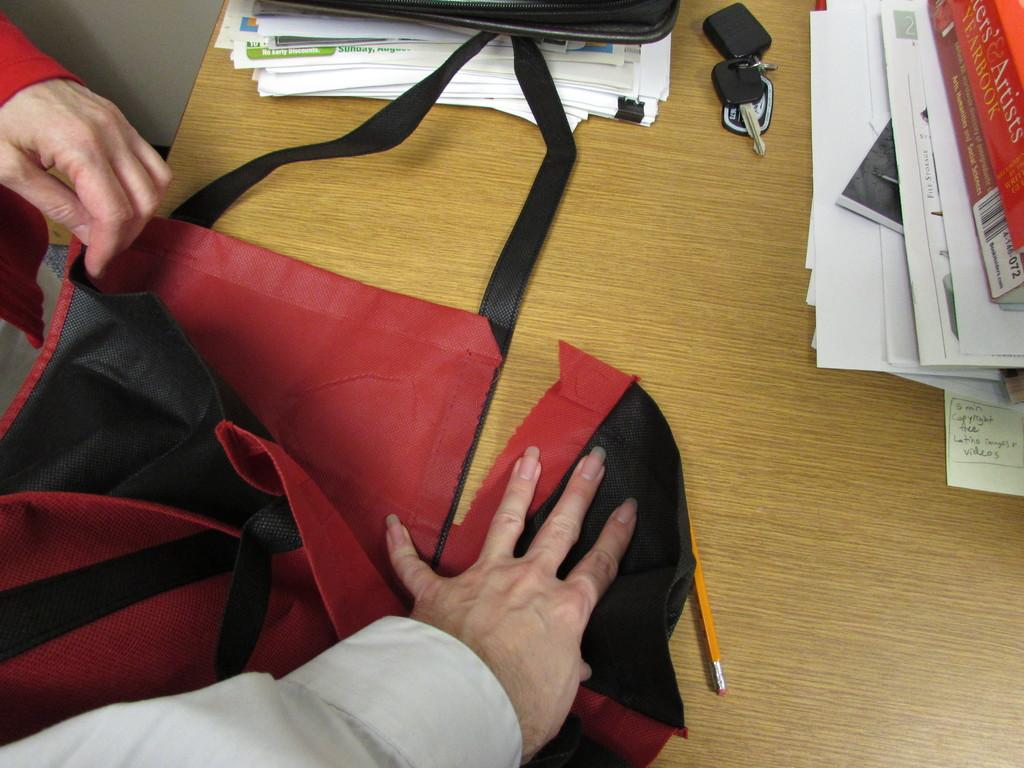Who or what is present in the image? There is a person in the image. What is the person doing with their hand? The person's hand is on a bag. Where is the bag located? The bag is placed on a table. What else can be seen on the table? There are books, papers, and keys on the table. How does the heat affect the person in the image? There is no mention of heat in the image, so we cannot determine its effect on the person. 